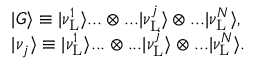Convert formula to latex. <formula><loc_0><loc_0><loc_500><loc_500>\begin{array} { r l } & { | G \rangle \equiv | \nu _ { L } ^ { 1 } \rangle \dots \otimes \dots | \nu _ { L } ^ { j } \rangle \otimes \dots | \nu _ { L } ^ { N } \rangle , } \\ & { | \nu _ { j } \rangle \equiv | \nu _ { L } ^ { 1 } \rangle \dots \otimes \dots | \nu _ { L } ^ { j } \rangle \otimes \dots | \nu _ { L } ^ { N } \rangle . } \end{array}</formula> 